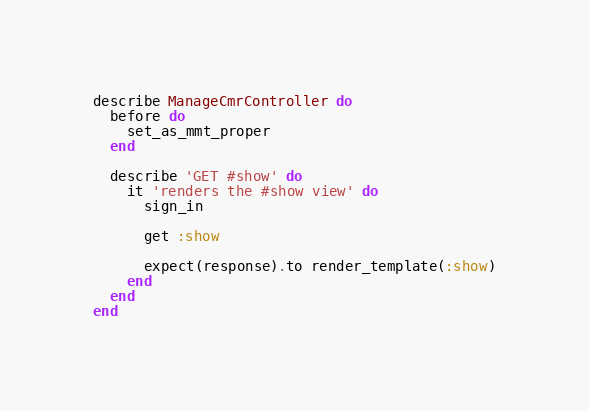Convert code to text. <code><loc_0><loc_0><loc_500><loc_500><_Ruby_>describe ManageCmrController do
  before do
    set_as_mmt_proper
  end

  describe 'GET #show' do
    it 'renders the #show view' do
      sign_in

      get :show

      expect(response).to render_template(:show)
    end
  end
end
</code> 